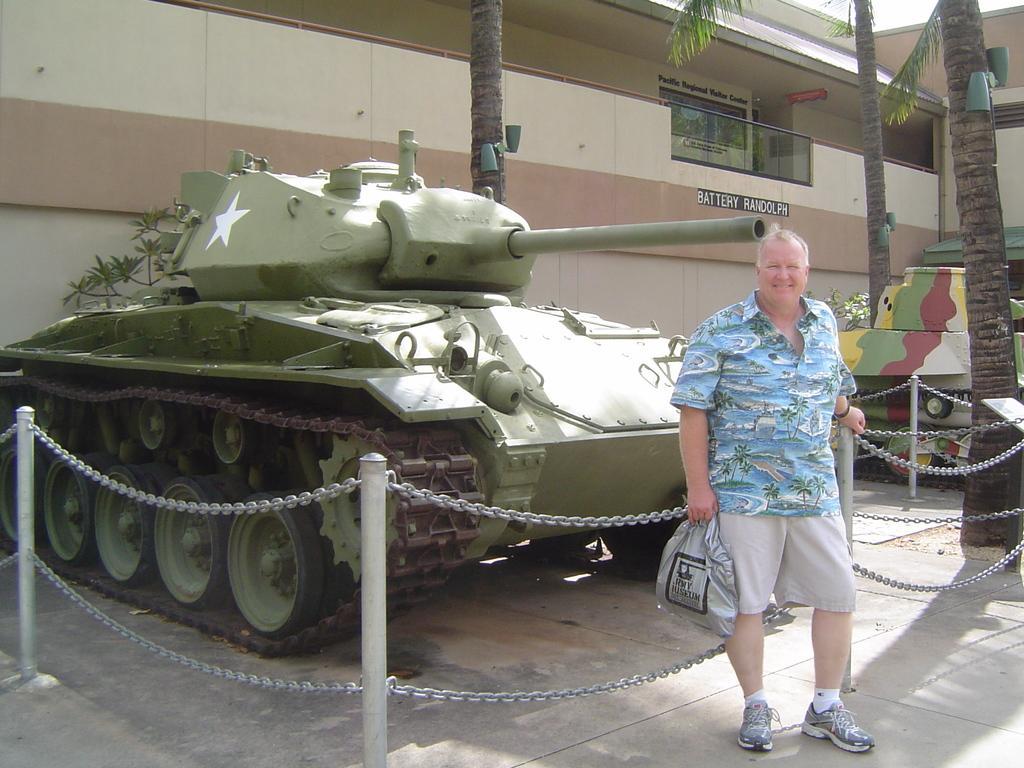Describe this image in one or two sentences. In this picture, we can see a person holding his bag and we can see some military tankers, fencing, trees, buildings, lights, plants and the sky and we can see the ground. 